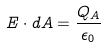Convert formula to latex. <formula><loc_0><loc_0><loc_500><loc_500>E \cdot d A = \frac { Q _ { A } } { \epsilon _ { 0 } }</formula> 